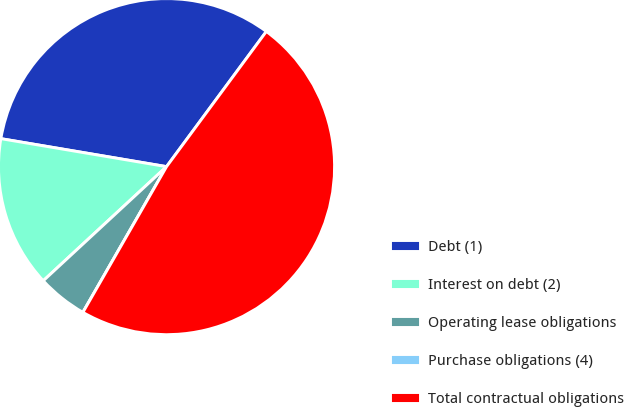Convert chart to OTSL. <chart><loc_0><loc_0><loc_500><loc_500><pie_chart><fcel>Debt (1)<fcel>Interest on debt (2)<fcel>Operating lease obligations<fcel>Purchase obligations (4)<fcel>Total contractual obligations<nl><fcel>32.46%<fcel>14.55%<fcel>4.82%<fcel>0.0%<fcel>48.17%<nl></chart> 